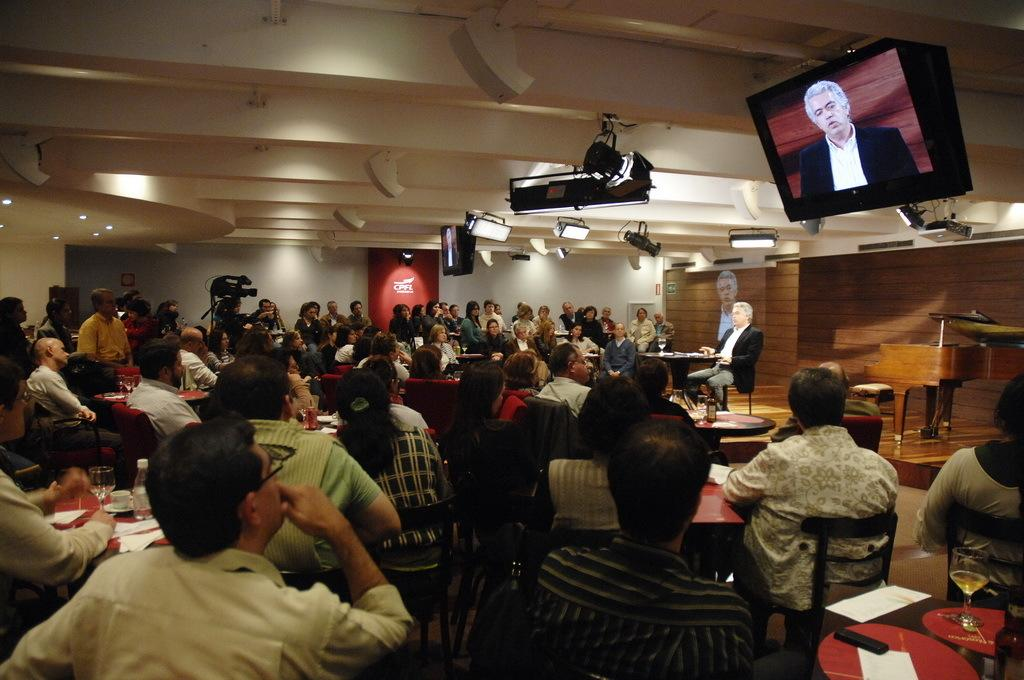How many people are in the image? There is a group of people in the image. What are the people doing in the image? The people are sitting on chairs. Where are the chairs located in relation to the table? The chairs are in front of a table. What can be seen on the right side of the image? There is a monitor or TV on the right side of the image. What type of lighting is present in the image? There are lights on the ceiling in the image. What type of coastline can be seen in the image? There is no coastline present in the image; it features a group of people sitting on chairs in front of a table. 